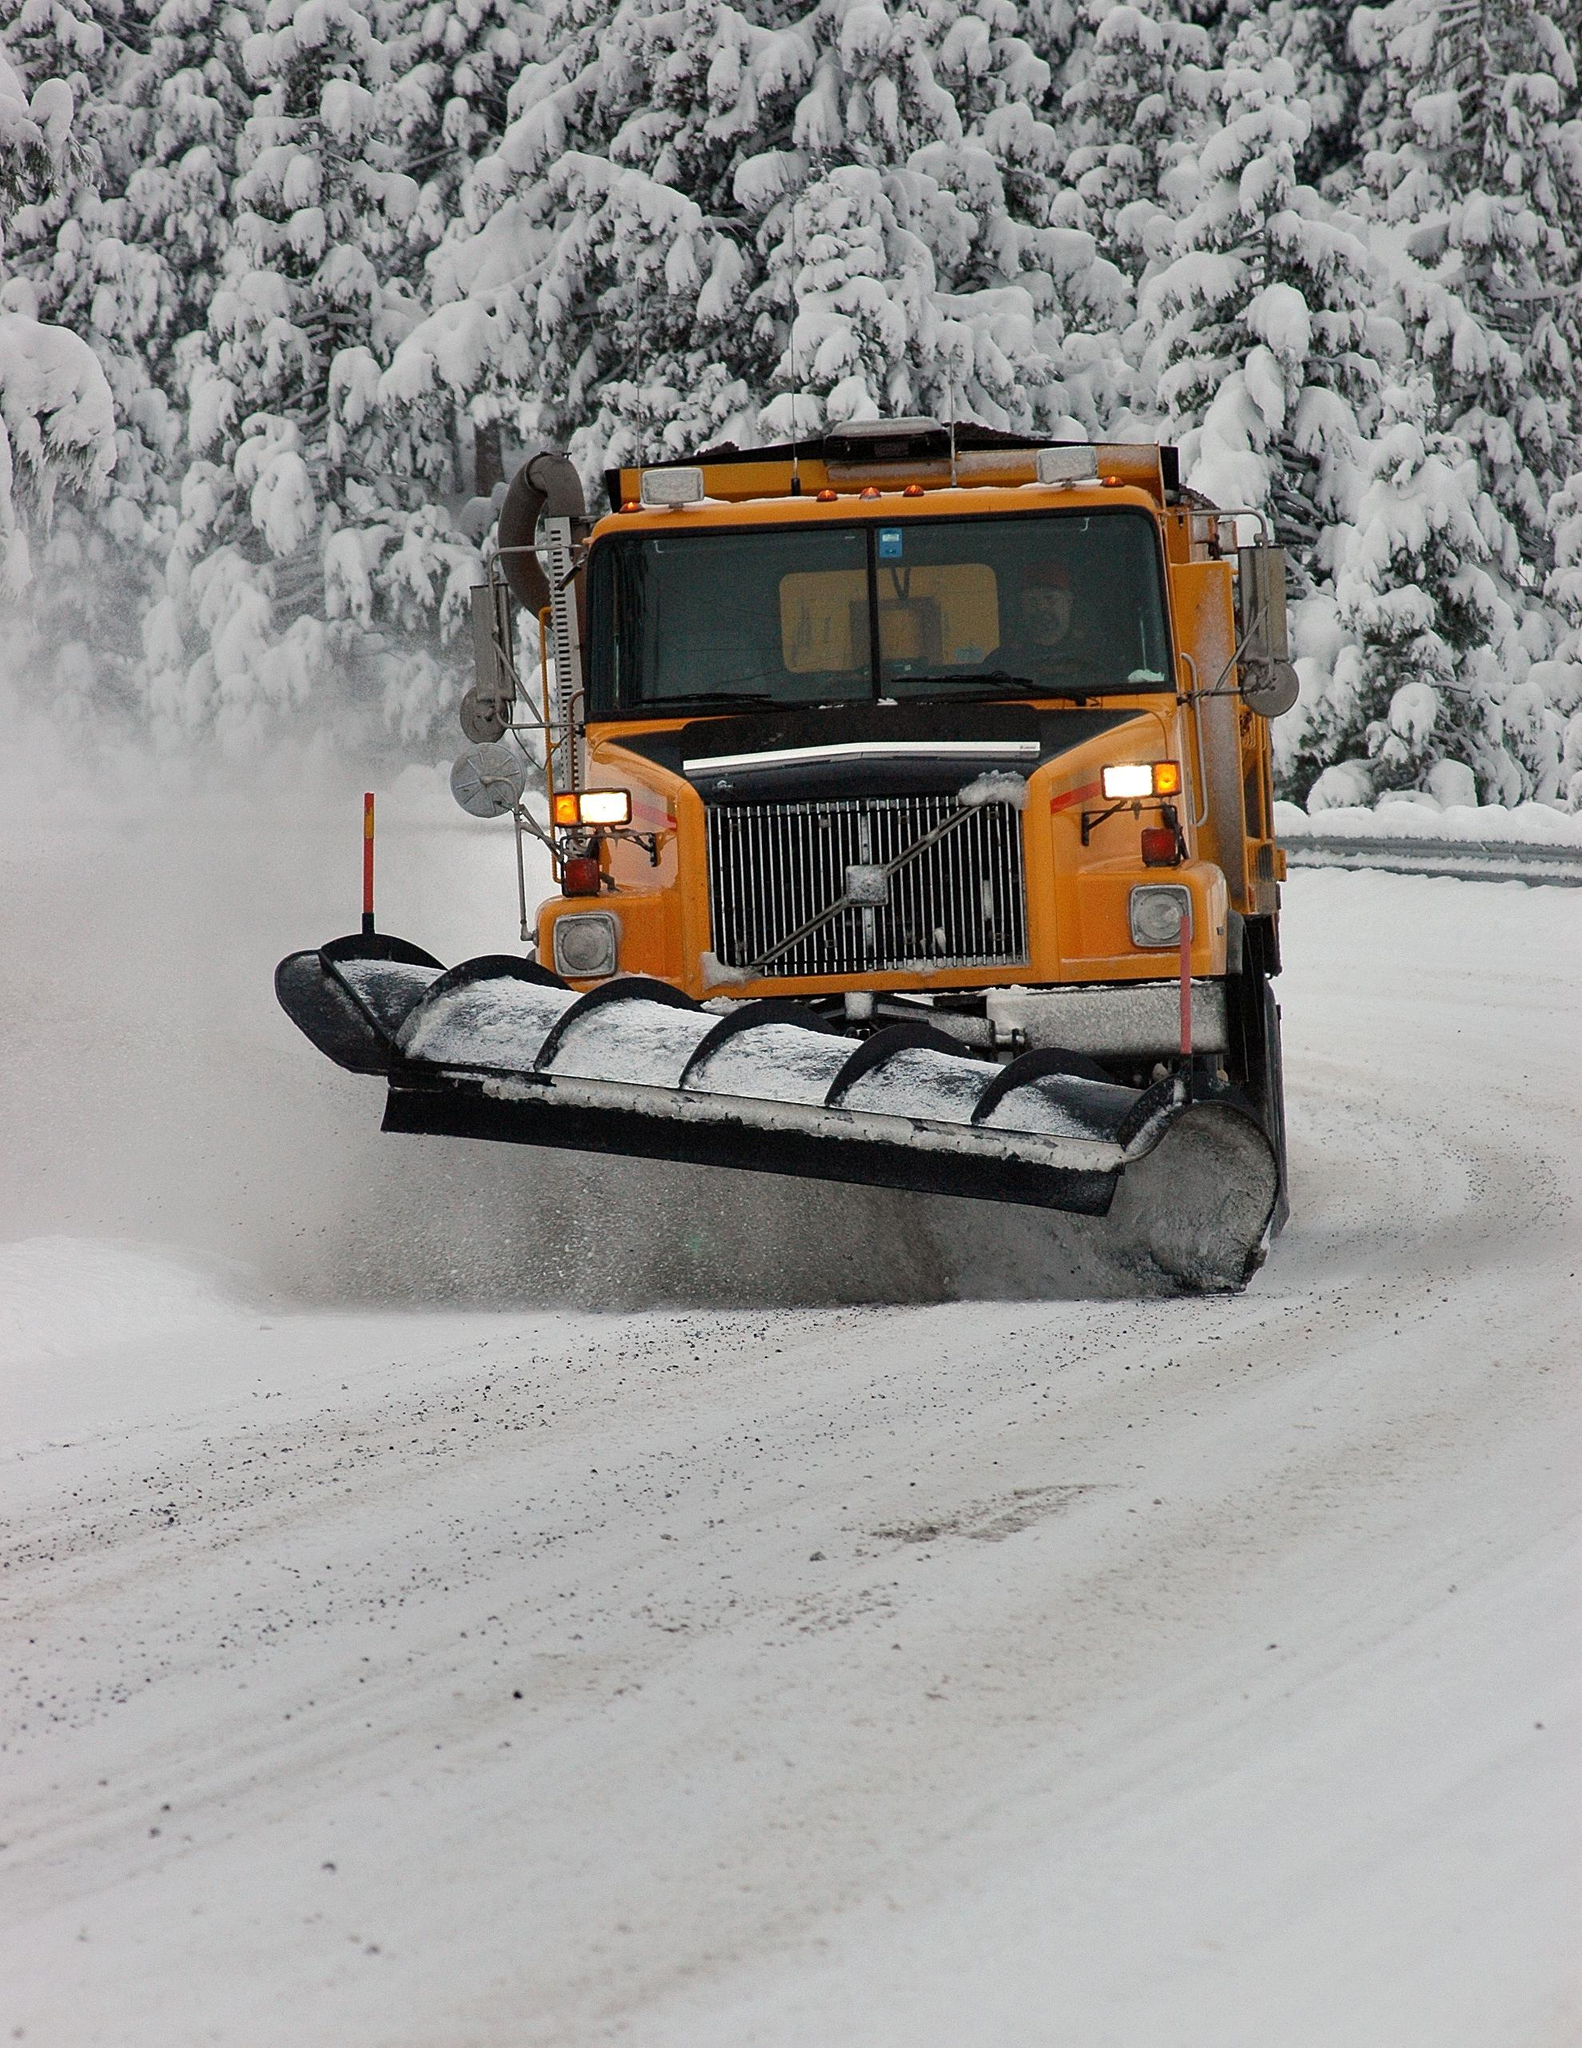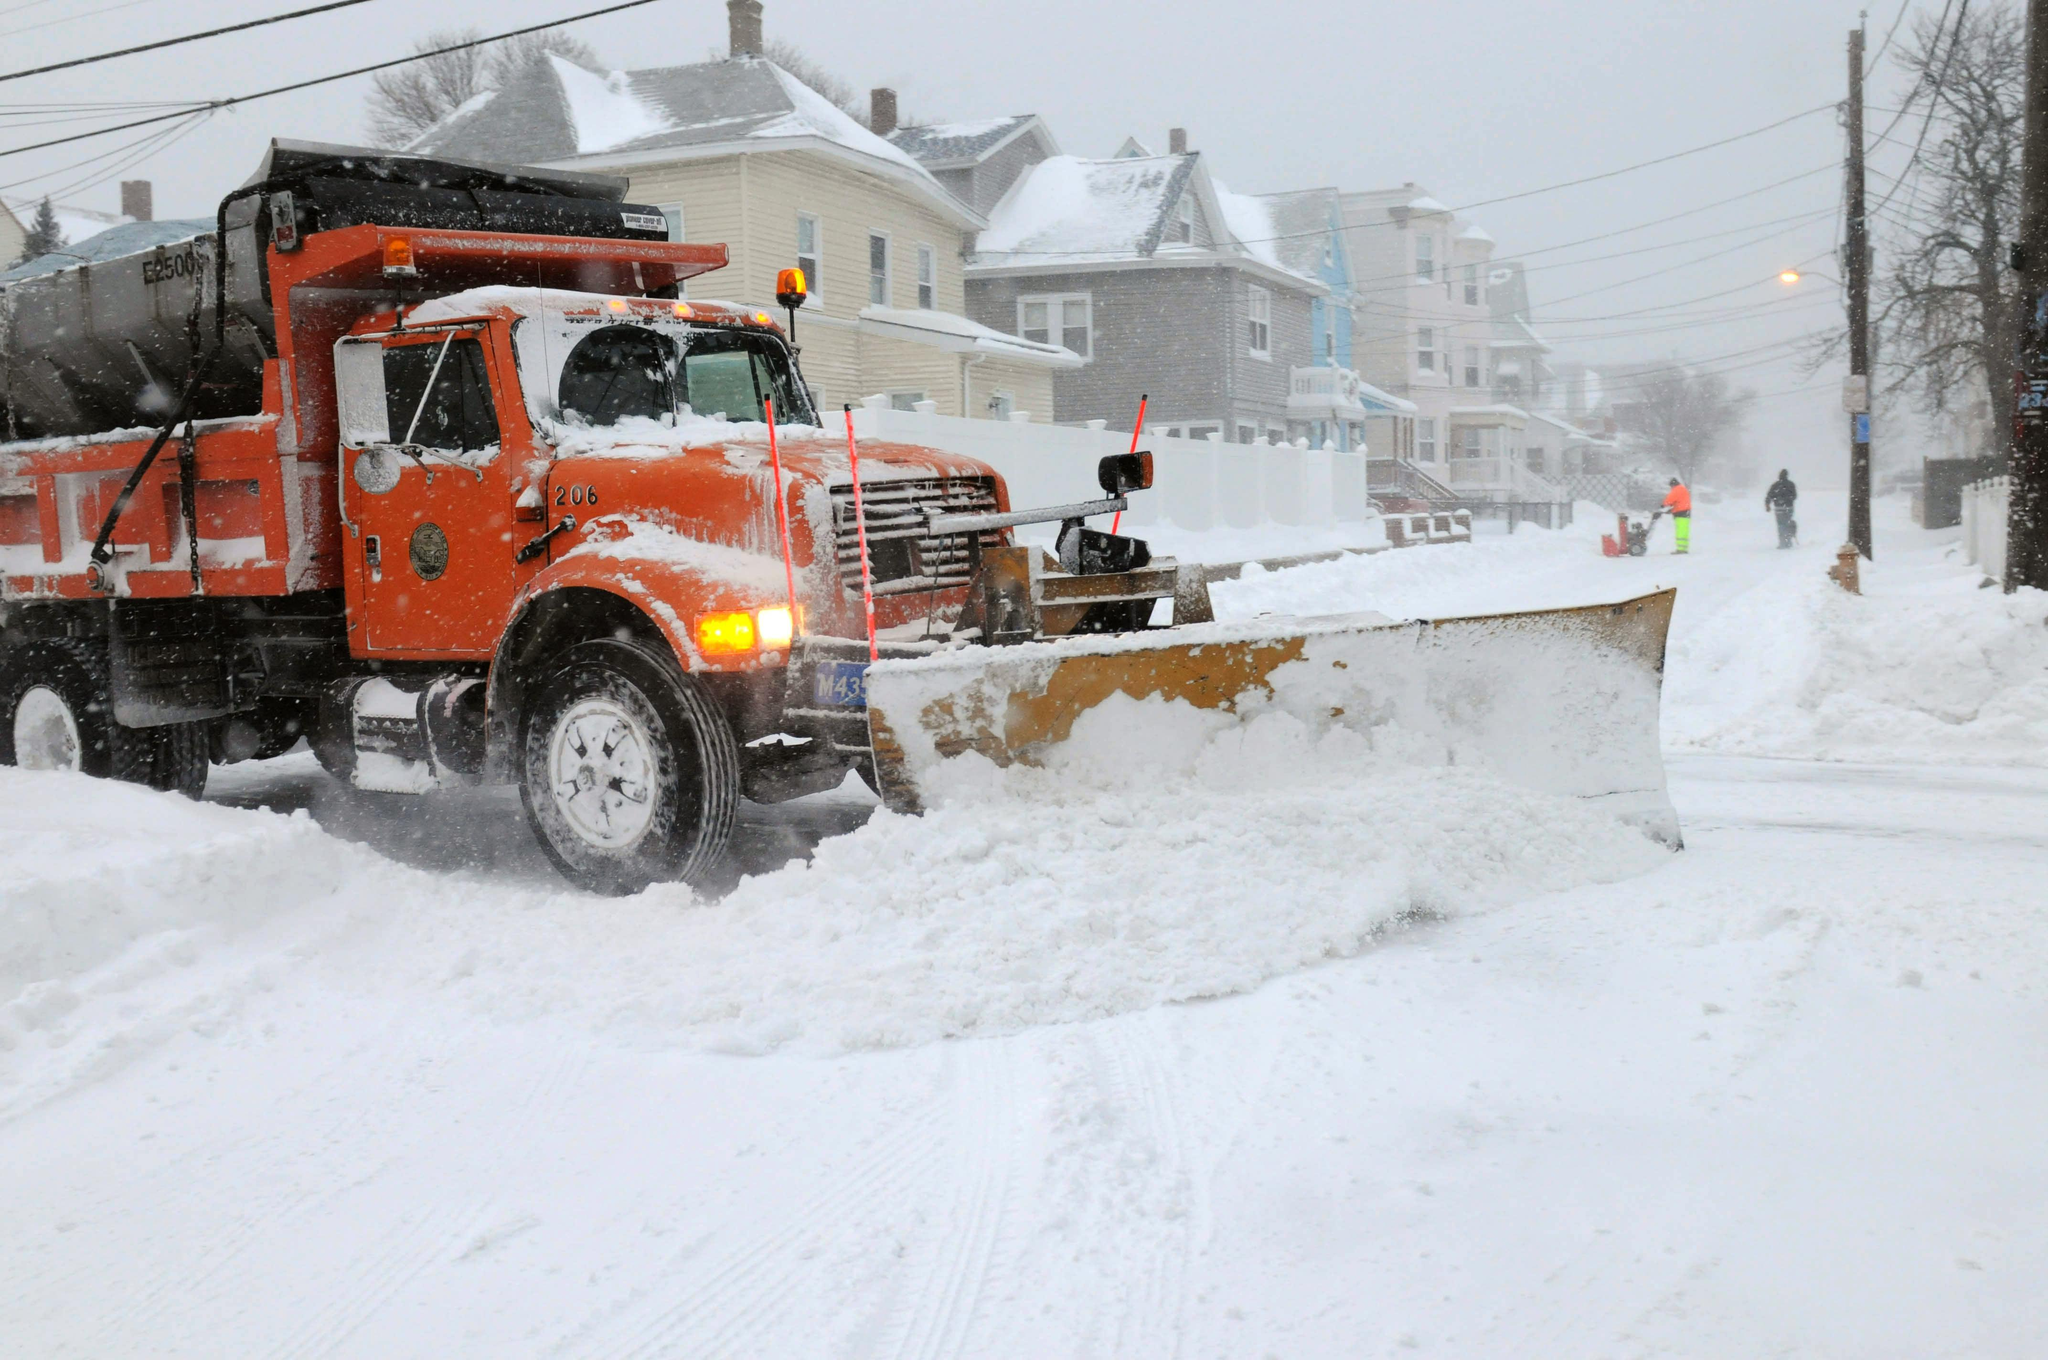The first image is the image on the left, the second image is the image on the right. For the images shown, is this caption "An image features a truck with an orange cab." true? Answer yes or no. Yes. 